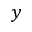Convert formula to latex. <formula><loc_0><loc_0><loc_500><loc_500>y</formula> 